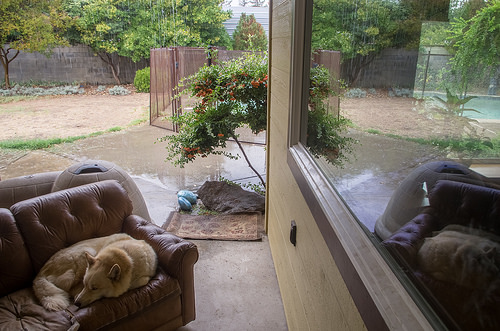<image>
Is there a tree in the yard? Yes. The tree is contained within or inside the yard, showing a containment relationship. Is there a plant in front of the dog? No. The plant is not in front of the dog. The spatial positioning shows a different relationship between these objects. 